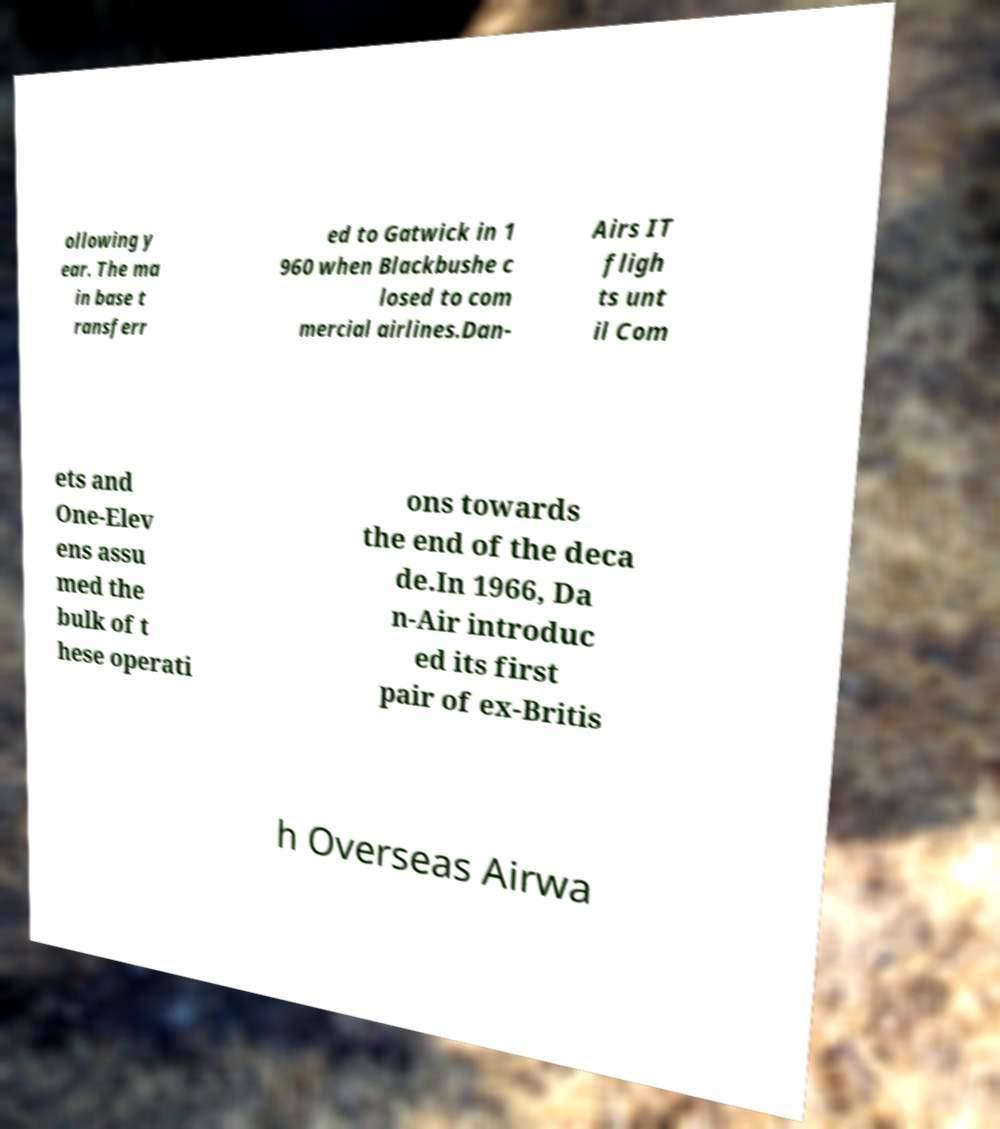Can you accurately transcribe the text from the provided image for me? ollowing y ear. The ma in base t ransferr ed to Gatwick in 1 960 when Blackbushe c losed to com mercial airlines.Dan- Airs IT fligh ts unt il Com ets and One-Elev ens assu med the bulk of t hese operati ons towards the end of the deca de.In 1966, Da n-Air introduc ed its first pair of ex-Britis h Overseas Airwa 